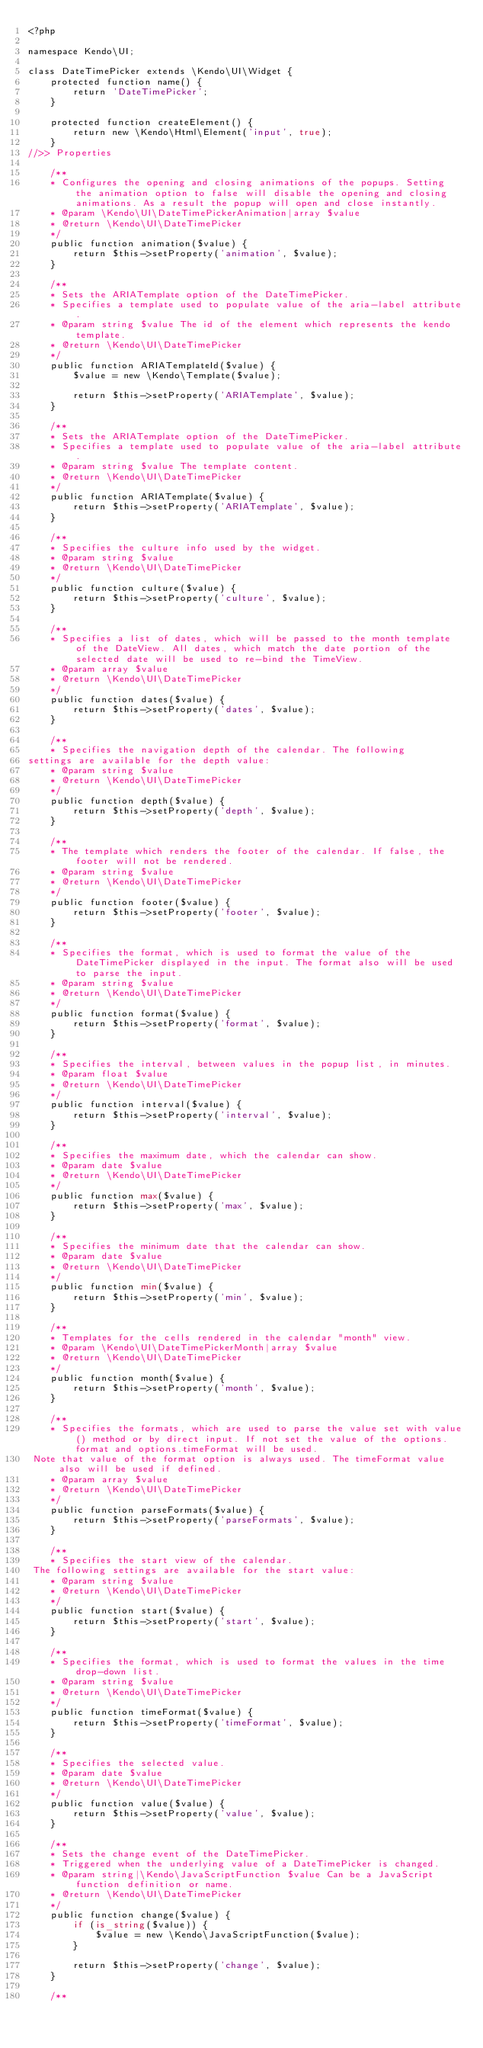<code> <loc_0><loc_0><loc_500><loc_500><_PHP_><?php

namespace Kendo\UI;

class DateTimePicker extends \Kendo\UI\Widget {
    protected function name() {
        return 'DateTimePicker';
    }

    protected function createElement() {
        return new \Kendo\Html\Element('input', true);
    }
//>> Properties

    /**
    * Configures the opening and closing animations of the popups. Setting the animation option to false will disable the opening and closing animations. As a result the popup will open and close instantly.
    * @param \Kendo\UI\DateTimePickerAnimation|array $value
    * @return \Kendo\UI\DateTimePicker
    */
    public function animation($value) {
        return $this->setProperty('animation', $value);
    }

    /**
    * Sets the ARIATemplate option of the DateTimePicker.
    * Specifies a template used to populate value of the aria-label attribute.
    * @param string $value The id of the element which represents the kendo template.
    * @return \Kendo\UI\DateTimePicker
    */
    public function ARIATemplateId($value) {
        $value = new \Kendo\Template($value);

        return $this->setProperty('ARIATemplate', $value);
    }

    /**
    * Sets the ARIATemplate option of the DateTimePicker.
    * Specifies a template used to populate value of the aria-label attribute.
    * @param string $value The template content.
    * @return \Kendo\UI\DateTimePicker
    */
    public function ARIATemplate($value) {
        return $this->setProperty('ARIATemplate', $value);
    }

    /**
    * Specifies the culture info used by the widget.
    * @param string $value
    * @return \Kendo\UI\DateTimePicker
    */
    public function culture($value) {
        return $this->setProperty('culture', $value);
    }

    /**
    * Specifies a list of dates, which will be passed to the month template of the DateView. All dates, which match the date portion of the selected date will be used to re-bind the TimeView.
    * @param array $value
    * @return \Kendo\UI\DateTimePicker
    */
    public function dates($value) {
        return $this->setProperty('dates', $value);
    }

    /**
    * Specifies the navigation depth of the calendar. The following
settings are available for the depth value:
    * @param string $value
    * @return \Kendo\UI\DateTimePicker
    */
    public function depth($value) {
        return $this->setProperty('depth', $value);
    }

    /**
    * The template which renders the footer of the calendar. If false, the footer will not be rendered.
    * @param string $value
    * @return \Kendo\UI\DateTimePicker
    */
    public function footer($value) {
        return $this->setProperty('footer', $value);
    }

    /**
    * Specifies the format, which is used to format the value of the DateTimePicker displayed in the input. The format also will be used to parse the input.
    * @param string $value
    * @return \Kendo\UI\DateTimePicker
    */
    public function format($value) {
        return $this->setProperty('format', $value);
    }

    /**
    * Specifies the interval, between values in the popup list, in minutes.
    * @param float $value
    * @return \Kendo\UI\DateTimePicker
    */
    public function interval($value) {
        return $this->setProperty('interval', $value);
    }

    /**
    * Specifies the maximum date, which the calendar can show.
    * @param date $value
    * @return \Kendo\UI\DateTimePicker
    */
    public function max($value) {
        return $this->setProperty('max', $value);
    }

    /**
    * Specifies the minimum date that the calendar can show.
    * @param date $value
    * @return \Kendo\UI\DateTimePicker
    */
    public function min($value) {
        return $this->setProperty('min', $value);
    }

    /**
    * Templates for the cells rendered in the calendar "month" view.
    * @param \Kendo\UI\DateTimePickerMonth|array $value
    * @return \Kendo\UI\DateTimePicker
    */
    public function month($value) {
        return $this->setProperty('month', $value);
    }

    /**
    * Specifies the formats, which are used to parse the value set with value() method or by direct input. If not set the value of the options.format and options.timeFormat will be used.
 Note that value of the format option is always used. The timeFormat value also will be used if defined.
    * @param array $value
    * @return \Kendo\UI\DateTimePicker
    */
    public function parseFormats($value) {
        return $this->setProperty('parseFormats', $value);
    }

    /**
    * Specifies the start view of the calendar.
 The following settings are available for the start value:
    * @param string $value
    * @return \Kendo\UI\DateTimePicker
    */
    public function start($value) {
        return $this->setProperty('start', $value);
    }

    /**
    * Specifies the format, which is used to format the values in the time drop-down list.
    * @param string $value
    * @return \Kendo\UI\DateTimePicker
    */
    public function timeFormat($value) {
        return $this->setProperty('timeFormat', $value);
    }

    /**
    * Specifies the selected value.
    * @param date $value
    * @return \Kendo\UI\DateTimePicker
    */
    public function value($value) {
        return $this->setProperty('value', $value);
    }

    /**
    * Sets the change event of the DateTimePicker.
    * Triggered when the underlying value of a DateTimePicker is changed.
    * @param string|\Kendo\JavaScriptFunction $value Can be a JavaScript function definition or name.
    * @return \Kendo\UI\DateTimePicker
    */
    public function change($value) {
        if (is_string($value)) {
            $value = new \Kendo\JavaScriptFunction($value);
        }

        return $this->setProperty('change', $value);
    }

    /**</code> 